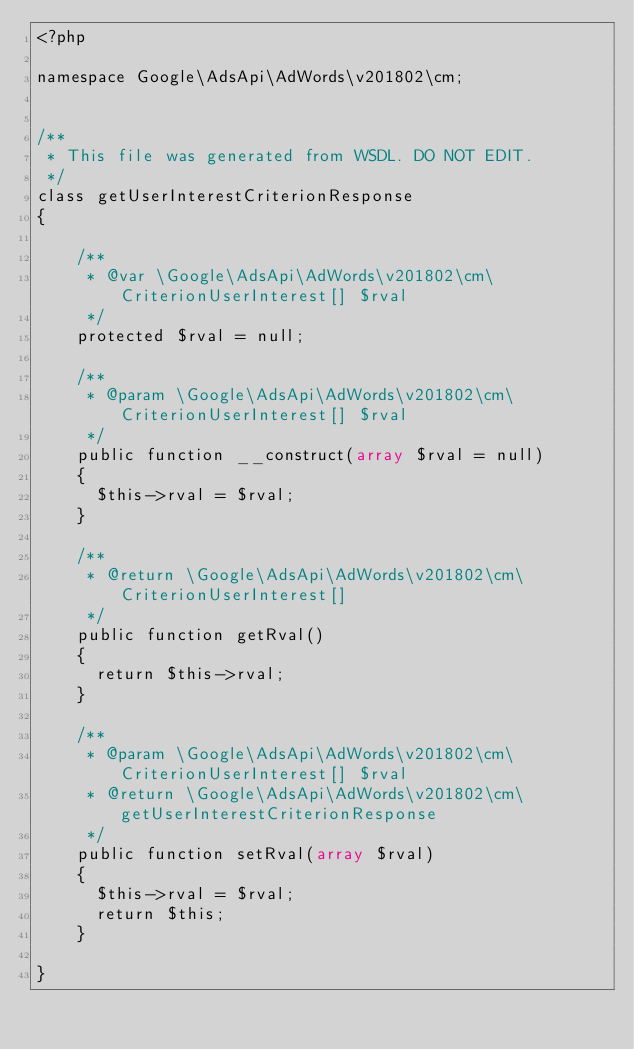<code> <loc_0><loc_0><loc_500><loc_500><_PHP_><?php

namespace Google\AdsApi\AdWords\v201802\cm;


/**
 * This file was generated from WSDL. DO NOT EDIT.
 */
class getUserInterestCriterionResponse
{

    /**
     * @var \Google\AdsApi\AdWords\v201802\cm\CriterionUserInterest[] $rval
     */
    protected $rval = null;

    /**
     * @param \Google\AdsApi\AdWords\v201802\cm\CriterionUserInterest[] $rval
     */
    public function __construct(array $rval = null)
    {
      $this->rval = $rval;
    }

    /**
     * @return \Google\AdsApi\AdWords\v201802\cm\CriterionUserInterest[]
     */
    public function getRval()
    {
      return $this->rval;
    }

    /**
     * @param \Google\AdsApi\AdWords\v201802\cm\CriterionUserInterest[] $rval
     * @return \Google\AdsApi\AdWords\v201802\cm\getUserInterestCriterionResponse
     */
    public function setRval(array $rval)
    {
      $this->rval = $rval;
      return $this;
    }

}
</code> 